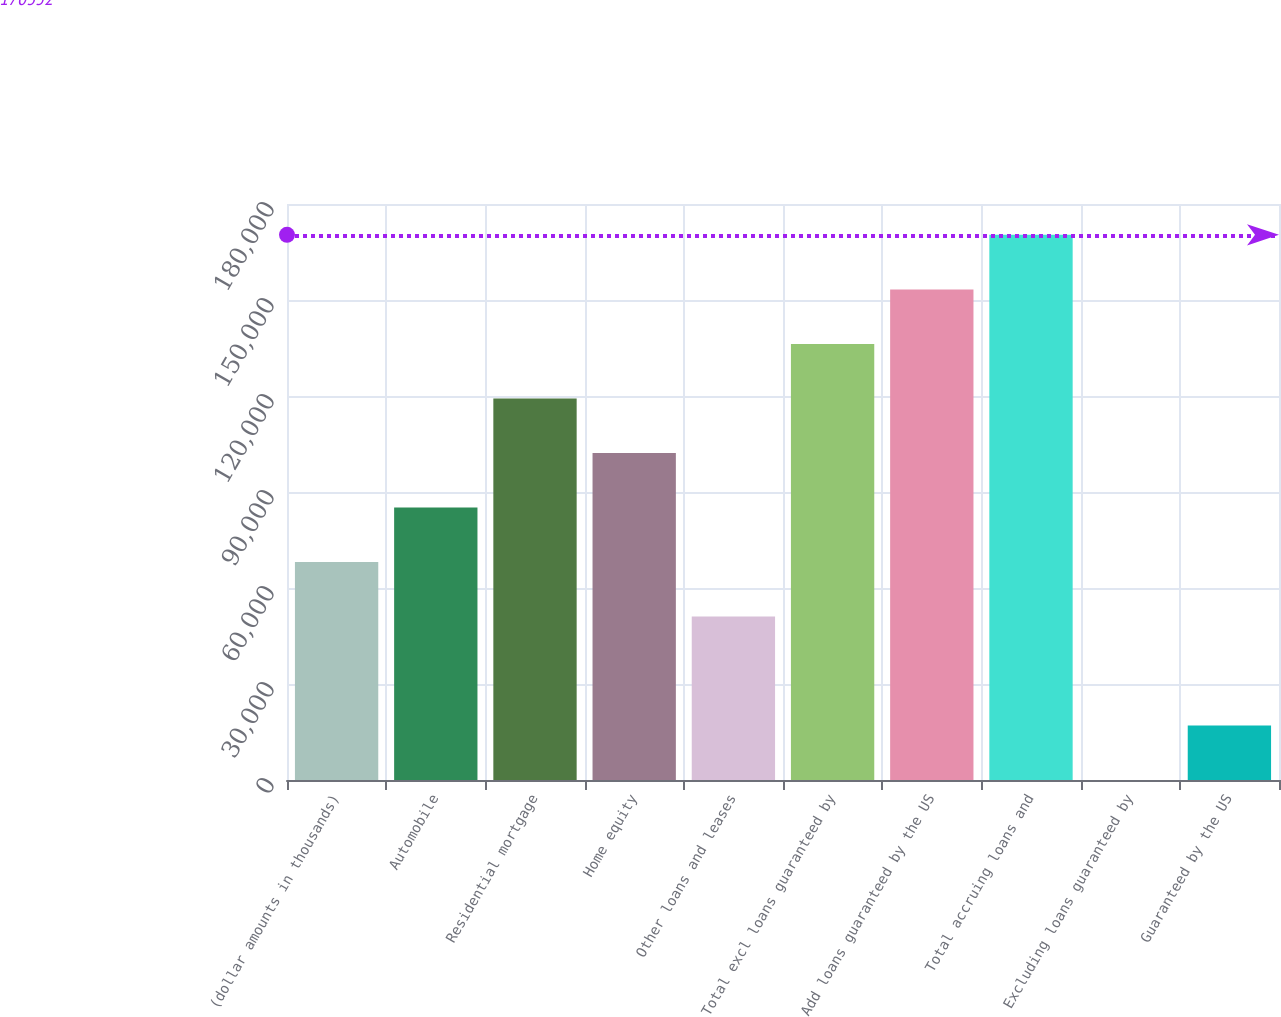Convert chart. <chart><loc_0><loc_0><loc_500><loc_500><bar_chart><fcel>(dollar amounts in thousands)<fcel>Automobile<fcel>Residential mortgage<fcel>Home equity<fcel>Other loans and leases<fcel>Total excl loans guaranteed by<fcel>Add loans guaranteed by the US<fcel>Total accruing loans and<fcel>Excluding loans guaranteed by<fcel>Guaranteed by the US<nl><fcel>68140.9<fcel>85176.1<fcel>119246<fcel>102211<fcel>51105.7<fcel>136282<fcel>153317<fcel>170352<fcel>0.19<fcel>17035.4<nl></chart> 